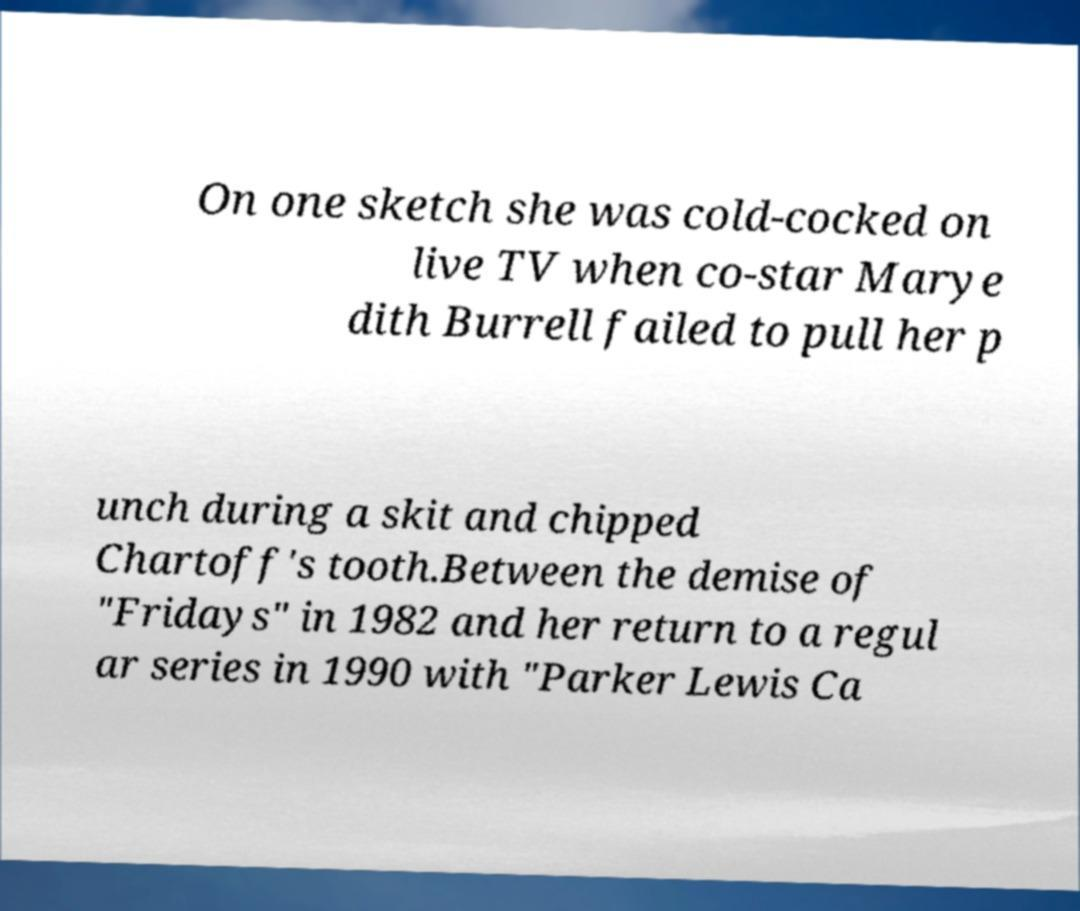Could you assist in decoding the text presented in this image and type it out clearly? On one sketch she was cold-cocked on live TV when co-star Marye dith Burrell failed to pull her p unch during a skit and chipped Chartoff's tooth.Between the demise of "Fridays" in 1982 and her return to a regul ar series in 1990 with "Parker Lewis Ca 